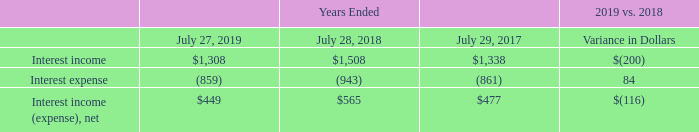Interest and Other Income (Loss), Net
Interest Income (Expense), Net The following table summarizes interest income and interest expense (in millions):
Interest income decreased, driven by a decrease in the average balance of cash and available-for-sale debt investments. The decrease in interest expense was driven by a lower average debt balance, partially offset by the impact of higher effective interest rates.
Why did interest income decrease? Driven by a decrease in the average balance of cash and available-for-sale debt investments. Which years does the table provide information for interest income and interest expense? 2019, 2018, 2017. What was the interest expense in 2017?
Answer scale should be: million. (861). What was the change in Interest expense between 2017 and 2018?
Answer scale should be: million. -943-(-861)
Answer: -82. What was the change in Interest income between 2018 and 2019?
Answer scale should be: million. 1,308-1,508
Answer: -200. What was the percentage change in the net interest income (expense) between 2018 and 2019?
Answer scale should be: percent. (449-565)/565
Answer: -20.53. 